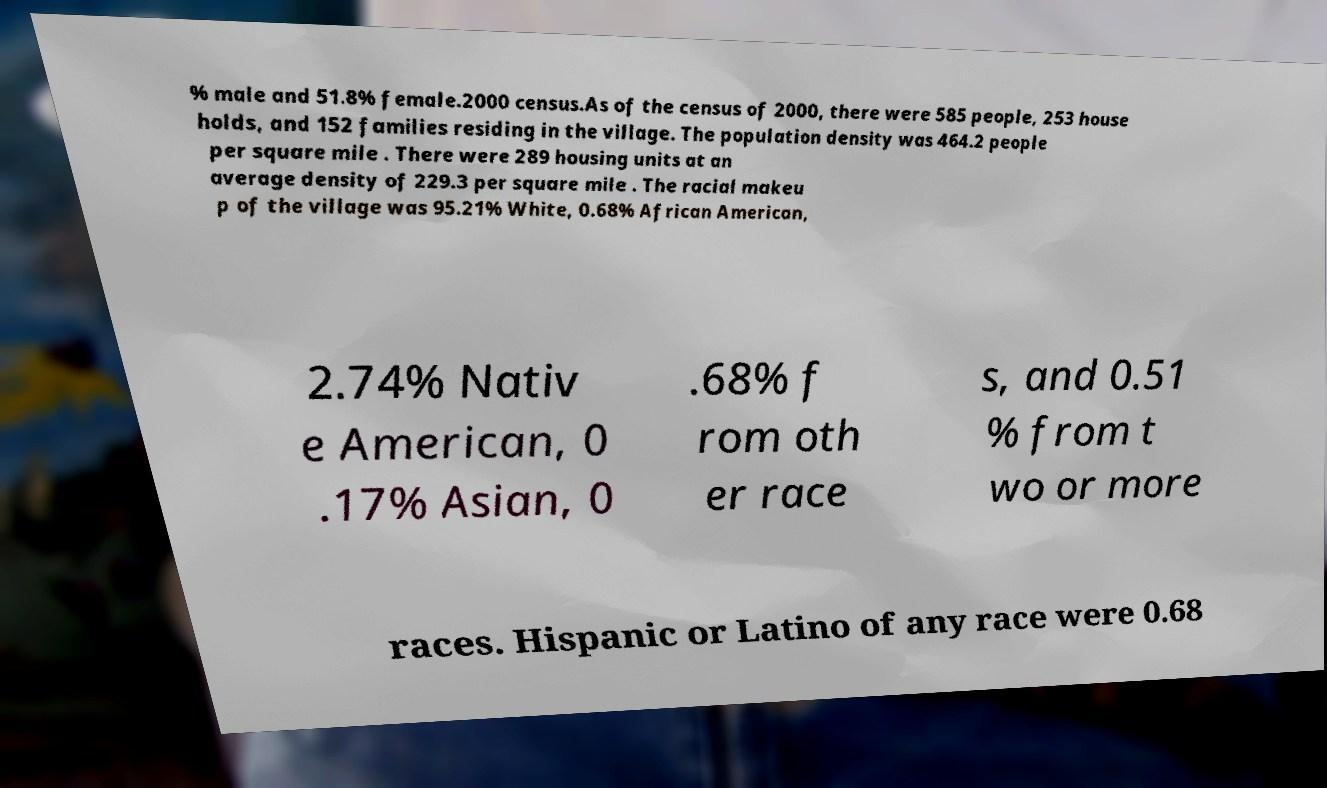Please identify and transcribe the text found in this image. % male and 51.8% female.2000 census.As of the census of 2000, there were 585 people, 253 house holds, and 152 families residing in the village. The population density was 464.2 people per square mile . There were 289 housing units at an average density of 229.3 per square mile . The racial makeu p of the village was 95.21% White, 0.68% African American, 2.74% Nativ e American, 0 .17% Asian, 0 .68% f rom oth er race s, and 0.51 % from t wo or more races. Hispanic or Latino of any race were 0.68 